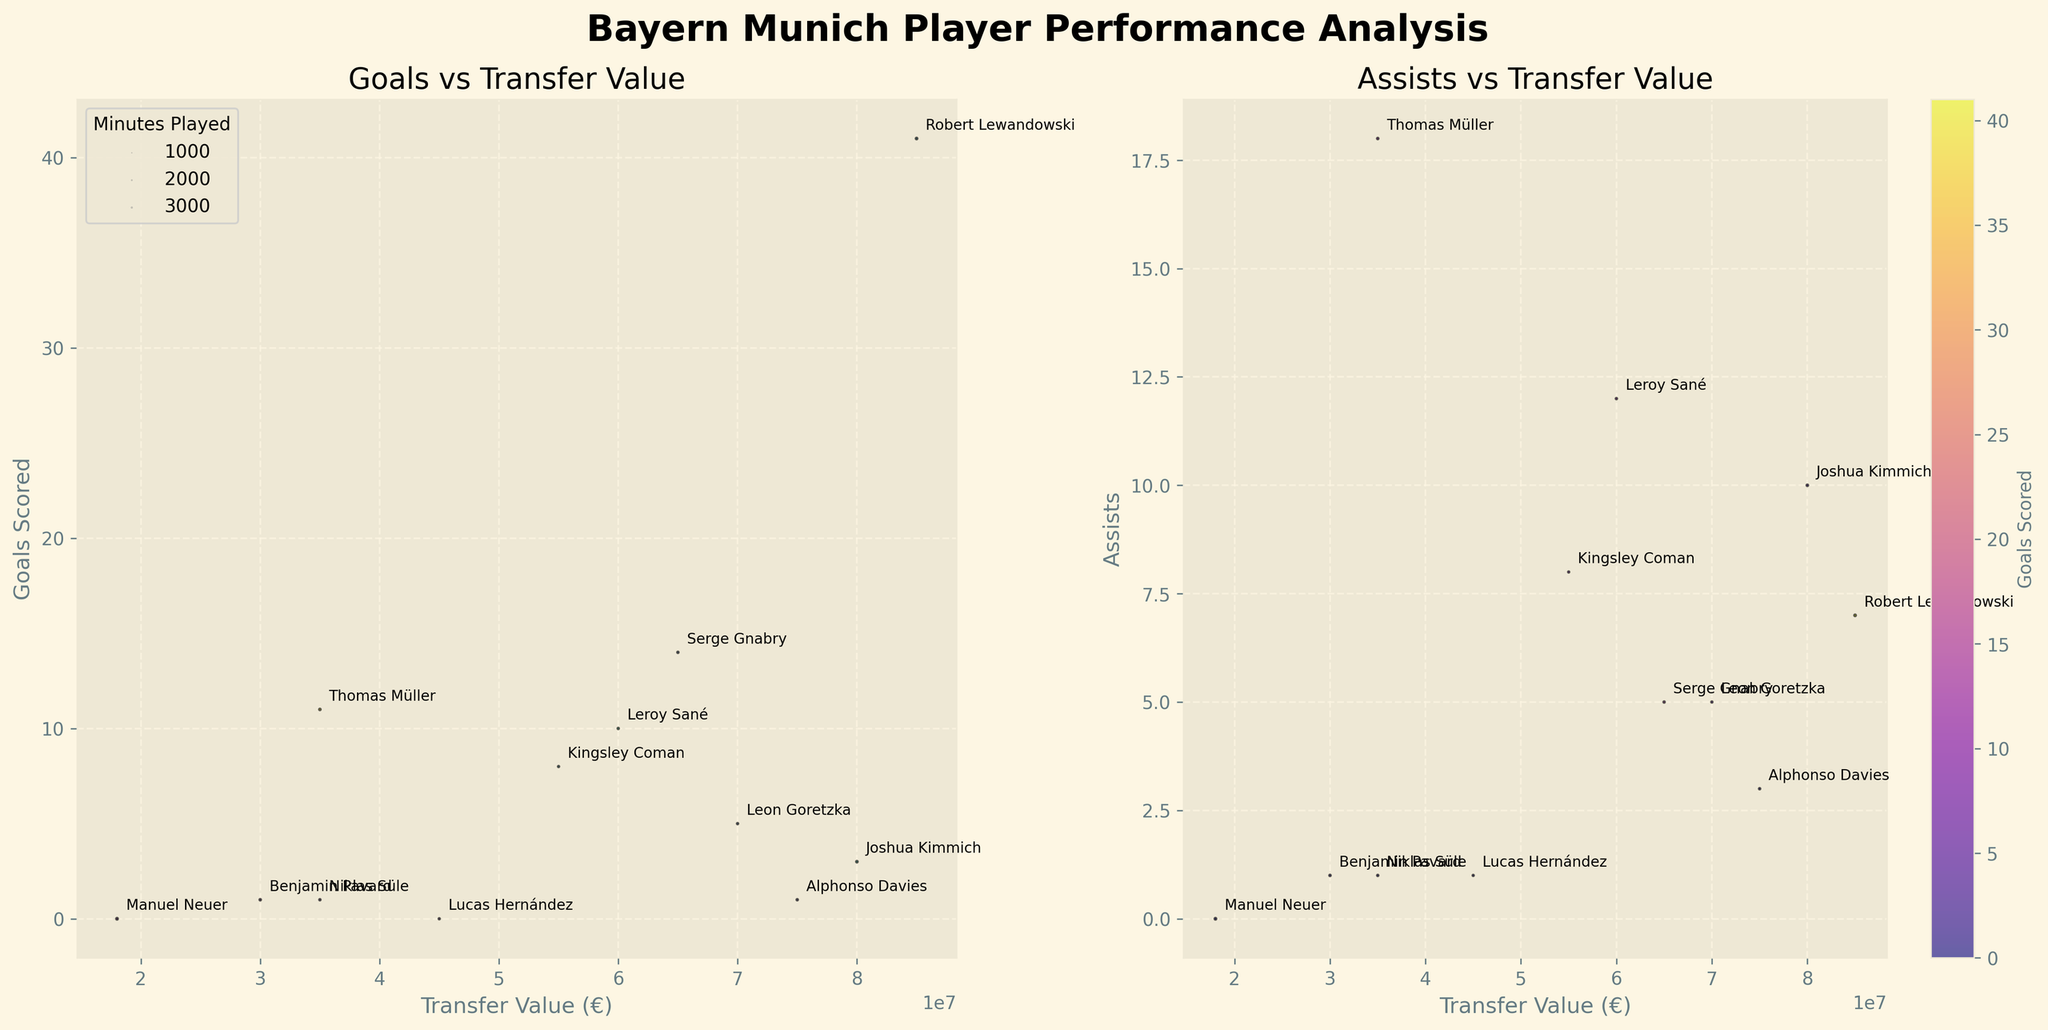Which player has the highest transfer value? The player with the highest transfer value is the one positioned the furthest to the right on the x-axis of both plots. This player is Robert Lewandowski with a transfer value of €85,000,000.
Answer: Robert Lewandowski Which player has scored the most goals? The player with the highest goals scored is the one located at the highest point on the y-axis in the first plot. This player is Robert Lewandowski with 41 goals.
Answer: Robert Lewandowski How many assists has Thomas Müller provided? Find Thomas Müller's data point in both plots. The assists value is depicted on the y-axis in the second plot. Thomas Müller has provided 18 assists.
Answer: 18 Who has played the most minutes? The player with the largest bubble represents the one who has played the most minutes. From the largest bubble in both plots, Manuel Neuer has played the most minutes, totaling 2790.
Answer: Manuel Neuer Which player has the lowest transfer value but still contributed in assists? Find the player positioned the furthest to the left of the x-axis on the second plot who has a non-zero value on the y-axis (assists). This player is Benjamin Pavard with a transfer value of €30,000,000 and 1 assist.
Answer: Benjamin Pavard Compare Robert Lewandowski and Serge Gnabry in terms of goals scored and assists. Who has a better overall performance? Robert Lewandowski has scored 41 goals and provided 7 assists. Serge Gnabry has scored 14 goals and provided 5 assists. In total, Robert Lewandowski contributed to 48 goals (41 goals + 7 assists), whereas Serge Gnabry contributed to 19 goals (14 goals + 5 assists). Thus, Robert Lewandowski has a better overall performance.
Answer: Robert Lewandowski Which player has the highest goals-to-minutes played ratio? Calculate the goals-to-minutes played ratio for each player and compare. For example, Robert Lewandowski: 41/2458 ≈ 0.0167; Serge Gnabry: 14/1901 ≈ 0.0074, etc. The player with the highest ratio will be chosen.
Answer: Robert Lewandowski Who has more assists, Joshua Kimmich or Leroy Sané? Compare the assists value on the second plot's y-axis for Joshua Kimmich and Leroy Sané by locating their respective data points. Joshua Kimmich has 10 assists, while Leroy Sané has 12 assists.
Answer: Leroy Sané What is the relationship between transfer value and goals scored? Examine the first plot for patterns or trends. Generally, players with higher transfer values (to the right of the x-axis) tend to have higher goals scored (higher on the y-axis), but there are some exceptions.
Answer: Higher transfer value often correlates with more goals scored 